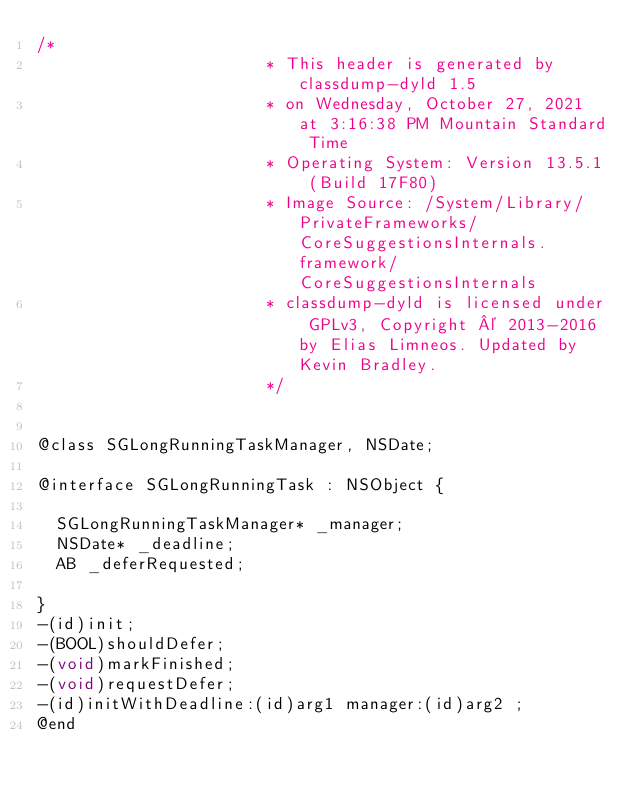Convert code to text. <code><loc_0><loc_0><loc_500><loc_500><_C_>/*
                       * This header is generated by classdump-dyld 1.5
                       * on Wednesday, October 27, 2021 at 3:16:38 PM Mountain Standard Time
                       * Operating System: Version 13.5.1 (Build 17F80)
                       * Image Source: /System/Library/PrivateFrameworks/CoreSuggestionsInternals.framework/CoreSuggestionsInternals
                       * classdump-dyld is licensed under GPLv3, Copyright © 2013-2016 by Elias Limneos. Updated by Kevin Bradley.
                       */


@class SGLongRunningTaskManager, NSDate;

@interface SGLongRunningTask : NSObject {

	SGLongRunningTaskManager* _manager;
	NSDate* _deadline;
	AB _deferRequested;

}
-(id)init;
-(BOOL)shouldDefer;
-(void)markFinished;
-(void)requestDefer;
-(id)initWithDeadline:(id)arg1 manager:(id)arg2 ;
@end

</code> 